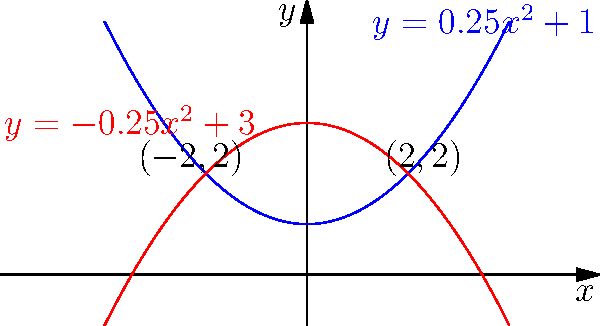As a successful entrepreneur, you're designing a luxurious infinity pool for your new mansion. The pool's cross-section is bounded by two polynomial curves: $y = 0.25x^2 + 1$ (bottom) and $y = -0.25x^2 + 3$ (top). If the width of the pool is 4 units, what is the area of the cross-section in square units? Round your answer to two decimal places. Let's approach this step-by-step:

1) The area between two curves is given by the integral of the difference between the upper and lower functions:

   $A = \int_{a}^{b} [f(x) - g(x)] dx$

   Where $f(x)$ is the upper curve and $g(x)$ is the lower curve.

2) In this case:
   $f(x) = -0.25x^2 + 3$
   $g(x) = 0.25x^2 + 1$

3) The width of the pool is 4 units, so the limits of integration are from -2 to 2.

4) Set up the integral:

   $A = \int_{-2}^{2} [(-0.25x^2 + 3) - (0.25x^2 + 1)] dx$

5) Simplify the integrand:

   $A = \int_{-2}^{2} [-0.5x^2 + 2] dx$

6) Integrate:

   $A = [-\frac{1}{6}x^3 + 2x]_{-2}^{2}$

7) Evaluate the integral:

   $A = [-\frac{1}{6}(2^3) + 2(2)] - [-\frac{1}{6}(-2^3) + 2(-2)]$
   $A = [-\frac{4}{3} + 4] - [\frac{4}{3} - 4]$
   $A = [\frac{8}{3}] - [-\frac{8}{3}]$
   $A = \frac{16}{3} = 5.33$ (rounded to two decimal places)

Therefore, the area of the pool's cross-section is approximately 5.33 square units.
Answer: 5.33 square units 